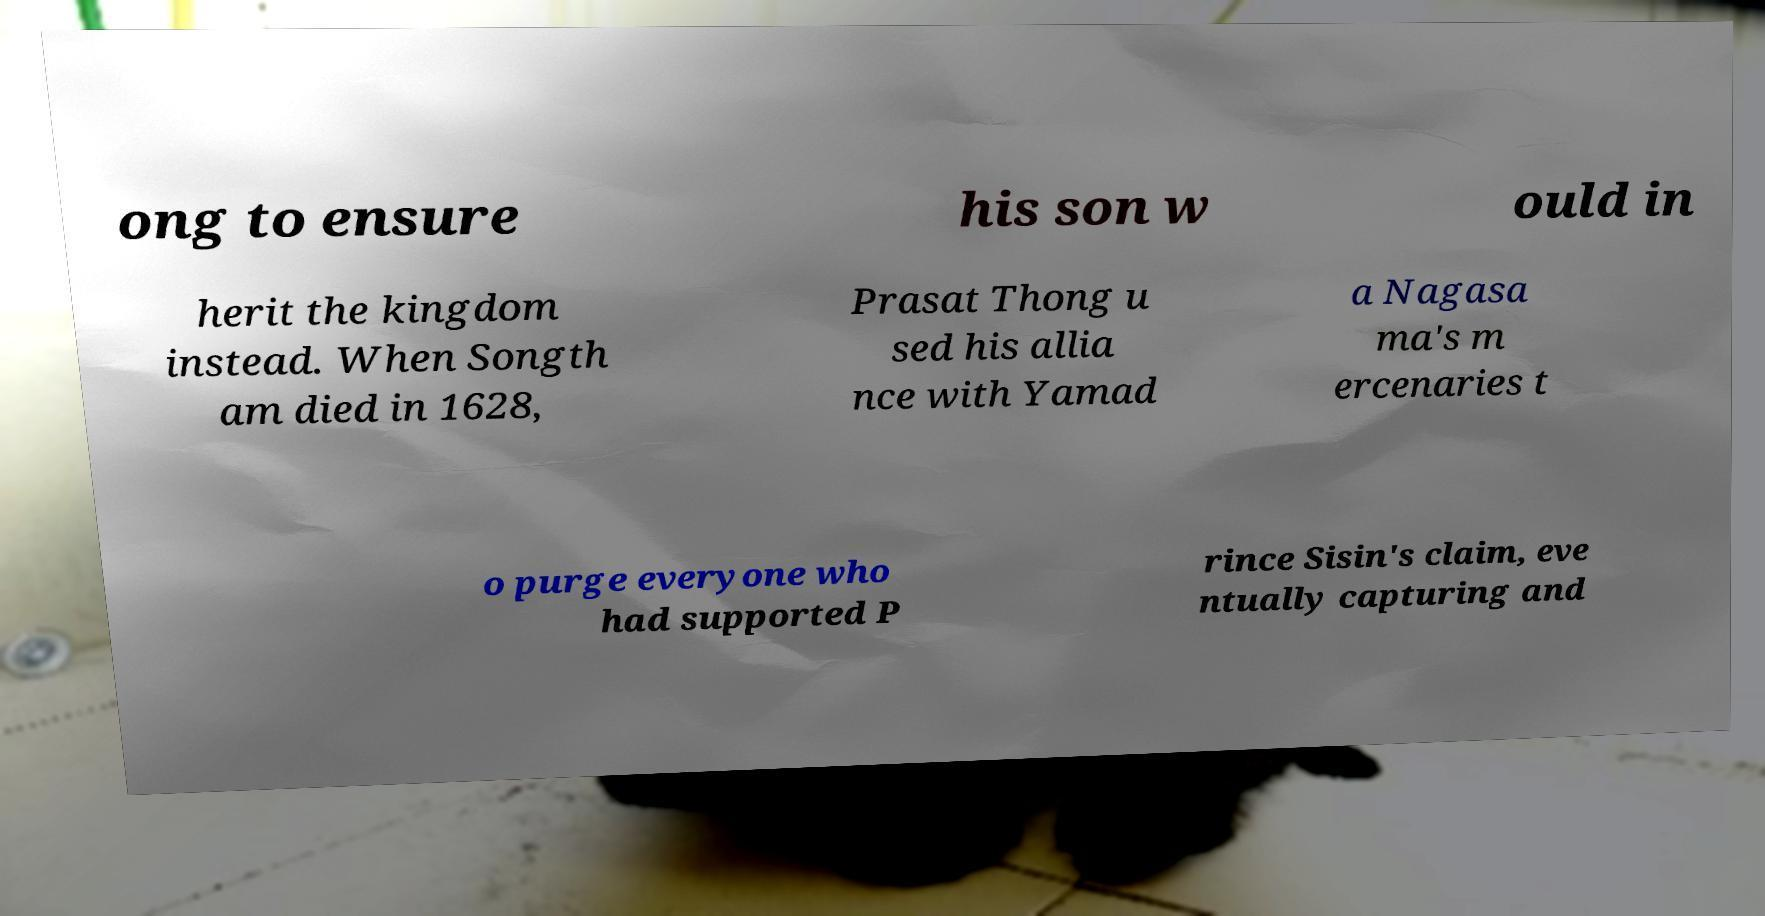Can you read and provide the text displayed in the image?This photo seems to have some interesting text. Can you extract and type it out for me? ong to ensure his son w ould in herit the kingdom instead. When Songth am died in 1628, Prasat Thong u sed his allia nce with Yamad a Nagasa ma's m ercenaries t o purge everyone who had supported P rince Sisin's claim, eve ntually capturing and 